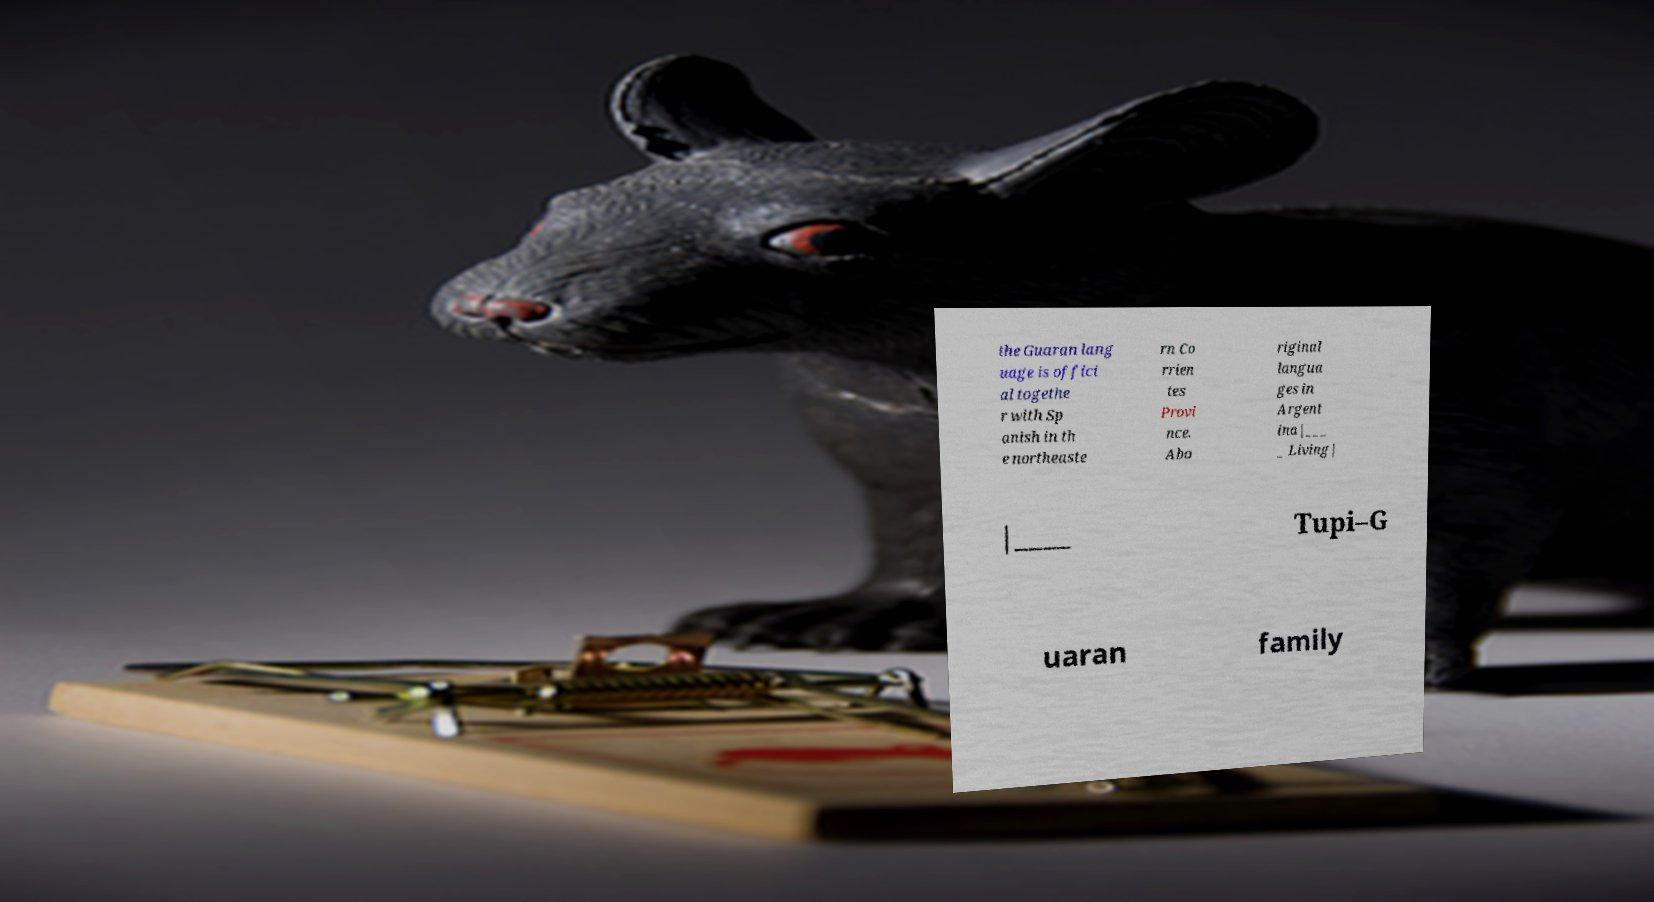I need the written content from this picture converted into text. Can you do that? the Guaran lang uage is offici al togethe r with Sp anish in th e northeaste rn Co rrien tes Provi nce. Abo riginal langua ges in Argent ina|___ _ Living| |____ Tupi–G uaran family 